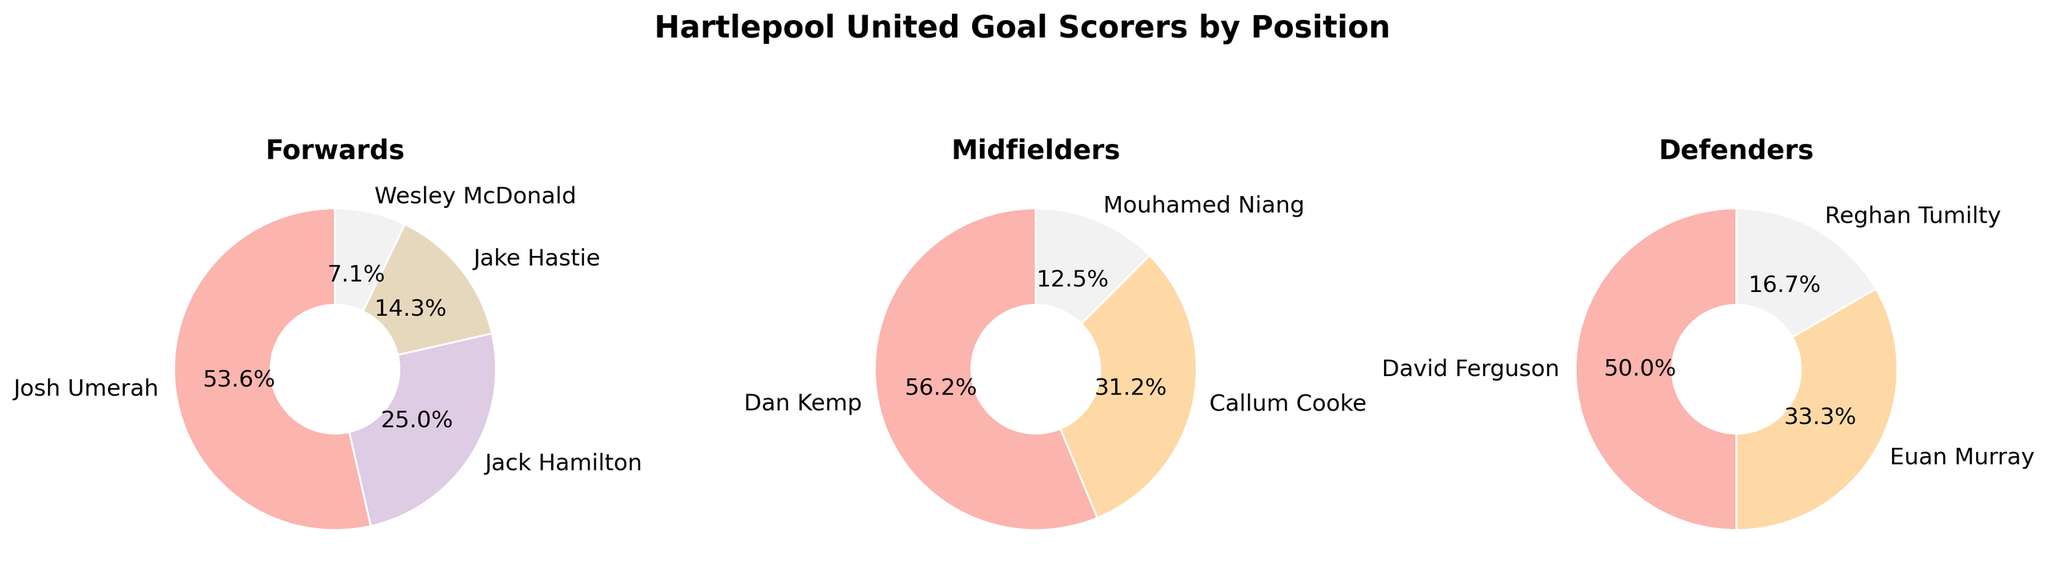What's the title of the figure? The title of the figure is displayed at the top in bold and larger font size. It provides a clear description of the content shown in the subplots.
Answer: "Hartlepool United Goal Scorers by Position" How many subplots are in the figure? Each pie chart represents a different position (Forward, Midfielder, Defender), which collectively form three subplots in total.
Answer: 3 Which Forward player scored the most goals? By looking at the Forward subplot, the largest pie segment represents the player. The name next to the largest slice is the one who scored the most goals.
Answer: Josh Umerah What’s the sum of goals scored by Forward players? The Forward pie chart shows the goals for each Forward. Summing them up, you get (15 + 7 + 4 + 2) = 28.
Answer: 28 Which position has the widest range of goals scored by different players? To determine the range, we subtract the smallest value from the largest value in each position's pie chart. Comparing them, the Forward position has the highest range (15-2=13), Midfielder (9-2=7), and Defender (3-1=2).
Answer: Forward Which Midfielder scored the fewest goals? Checking the Midfielder subplot, the smallest pie segment represents the player with the fewest goals. The name next to it identifies that player.
Answer: Mouhamed Niang Are there any positions where more than one player scored the same number of goals? By examining the pie charts, we see that the Forward subplot has two players (Wesley McDonald and Jake Hastie) each with 2 goals.
Answer: Yes How many players are there in total across all positions? The total number of unique players across all three pie charts can be counted: 4 (Forwards) + 4 (Midfielders) + 3 (Defenders) = 11.
Answer: 11 